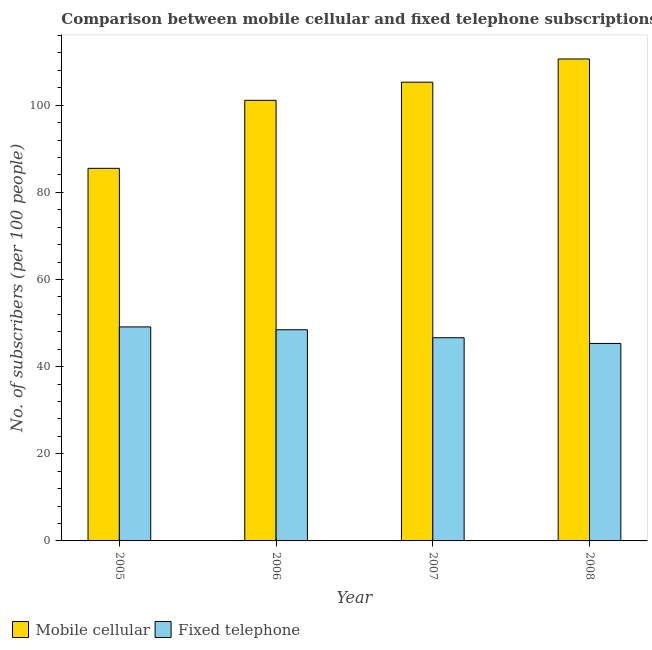How many different coloured bars are there?
Give a very brief answer. 2. Are the number of bars on each tick of the X-axis equal?
Offer a very short reply. Yes. How many bars are there on the 2nd tick from the left?
Your answer should be very brief. 2. What is the label of the 1st group of bars from the left?
Your answer should be very brief. 2005. In how many cases, is the number of bars for a given year not equal to the number of legend labels?
Make the answer very short. 0. What is the number of mobile cellular subscribers in 2007?
Provide a succinct answer. 105.28. Across all years, what is the maximum number of fixed telephone subscribers?
Provide a succinct answer. 49.11. Across all years, what is the minimum number of fixed telephone subscribers?
Provide a succinct answer. 45.32. In which year was the number of mobile cellular subscribers minimum?
Your answer should be very brief. 2005. What is the total number of fixed telephone subscribers in the graph?
Give a very brief answer. 189.53. What is the difference between the number of mobile cellular subscribers in 2006 and that in 2008?
Provide a succinct answer. -9.49. What is the difference between the number of mobile cellular subscribers in 2005 and the number of fixed telephone subscribers in 2006?
Give a very brief answer. -15.61. What is the average number of fixed telephone subscribers per year?
Your response must be concise. 47.38. In the year 2007, what is the difference between the number of fixed telephone subscribers and number of mobile cellular subscribers?
Your response must be concise. 0. What is the ratio of the number of mobile cellular subscribers in 2005 to that in 2008?
Provide a short and direct response. 0.77. Is the number of fixed telephone subscribers in 2005 less than that in 2006?
Offer a terse response. No. Is the difference between the number of mobile cellular subscribers in 2007 and 2008 greater than the difference between the number of fixed telephone subscribers in 2007 and 2008?
Give a very brief answer. No. What is the difference between the highest and the second highest number of fixed telephone subscribers?
Your answer should be very brief. 0.65. What is the difference between the highest and the lowest number of fixed telephone subscribers?
Offer a very short reply. 3.79. In how many years, is the number of mobile cellular subscribers greater than the average number of mobile cellular subscribers taken over all years?
Ensure brevity in your answer.  3. What does the 2nd bar from the left in 2005 represents?
Give a very brief answer. Fixed telephone. What does the 2nd bar from the right in 2008 represents?
Offer a terse response. Mobile cellular. How many bars are there?
Ensure brevity in your answer.  8. Are all the bars in the graph horizontal?
Offer a terse response. No. Does the graph contain any zero values?
Offer a very short reply. No. Where does the legend appear in the graph?
Ensure brevity in your answer.  Bottom left. What is the title of the graph?
Offer a terse response. Comparison between mobile cellular and fixed telephone subscriptions in Faeroe Islands. Does "Long-term debt" appear as one of the legend labels in the graph?
Keep it short and to the point. No. What is the label or title of the X-axis?
Keep it short and to the point. Year. What is the label or title of the Y-axis?
Give a very brief answer. No. of subscribers (per 100 people). What is the No. of subscribers (per 100 people) of Mobile cellular in 2005?
Your response must be concise. 85.51. What is the No. of subscribers (per 100 people) in Fixed telephone in 2005?
Offer a very short reply. 49.11. What is the No. of subscribers (per 100 people) of Mobile cellular in 2006?
Ensure brevity in your answer.  101.12. What is the No. of subscribers (per 100 people) of Fixed telephone in 2006?
Make the answer very short. 48.46. What is the No. of subscribers (per 100 people) of Mobile cellular in 2007?
Your answer should be compact. 105.28. What is the No. of subscribers (per 100 people) of Fixed telephone in 2007?
Offer a very short reply. 46.63. What is the No. of subscribers (per 100 people) in Mobile cellular in 2008?
Ensure brevity in your answer.  110.6. What is the No. of subscribers (per 100 people) in Fixed telephone in 2008?
Your response must be concise. 45.32. Across all years, what is the maximum No. of subscribers (per 100 people) of Mobile cellular?
Your response must be concise. 110.6. Across all years, what is the maximum No. of subscribers (per 100 people) of Fixed telephone?
Provide a succinct answer. 49.11. Across all years, what is the minimum No. of subscribers (per 100 people) of Mobile cellular?
Your response must be concise. 85.51. Across all years, what is the minimum No. of subscribers (per 100 people) of Fixed telephone?
Provide a short and direct response. 45.32. What is the total No. of subscribers (per 100 people) in Mobile cellular in the graph?
Provide a succinct answer. 402.5. What is the total No. of subscribers (per 100 people) in Fixed telephone in the graph?
Make the answer very short. 189.53. What is the difference between the No. of subscribers (per 100 people) of Mobile cellular in 2005 and that in 2006?
Your response must be concise. -15.61. What is the difference between the No. of subscribers (per 100 people) of Fixed telephone in 2005 and that in 2006?
Your answer should be very brief. 0.65. What is the difference between the No. of subscribers (per 100 people) of Mobile cellular in 2005 and that in 2007?
Give a very brief answer. -19.77. What is the difference between the No. of subscribers (per 100 people) of Fixed telephone in 2005 and that in 2007?
Ensure brevity in your answer.  2.48. What is the difference between the No. of subscribers (per 100 people) in Mobile cellular in 2005 and that in 2008?
Ensure brevity in your answer.  -25.1. What is the difference between the No. of subscribers (per 100 people) in Fixed telephone in 2005 and that in 2008?
Offer a terse response. 3.79. What is the difference between the No. of subscribers (per 100 people) in Mobile cellular in 2006 and that in 2007?
Provide a succinct answer. -4.16. What is the difference between the No. of subscribers (per 100 people) of Fixed telephone in 2006 and that in 2007?
Provide a short and direct response. 1.83. What is the difference between the No. of subscribers (per 100 people) in Mobile cellular in 2006 and that in 2008?
Give a very brief answer. -9.49. What is the difference between the No. of subscribers (per 100 people) of Fixed telephone in 2006 and that in 2008?
Ensure brevity in your answer.  3.14. What is the difference between the No. of subscribers (per 100 people) of Mobile cellular in 2007 and that in 2008?
Ensure brevity in your answer.  -5.33. What is the difference between the No. of subscribers (per 100 people) in Fixed telephone in 2007 and that in 2008?
Provide a short and direct response. 1.31. What is the difference between the No. of subscribers (per 100 people) in Mobile cellular in 2005 and the No. of subscribers (per 100 people) in Fixed telephone in 2006?
Your answer should be compact. 37.04. What is the difference between the No. of subscribers (per 100 people) in Mobile cellular in 2005 and the No. of subscribers (per 100 people) in Fixed telephone in 2007?
Make the answer very short. 38.87. What is the difference between the No. of subscribers (per 100 people) of Mobile cellular in 2005 and the No. of subscribers (per 100 people) of Fixed telephone in 2008?
Provide a short and direct response. 40.18. What is the difference between the No. of subscribers (per 100 people) in Mobile cellular in 2006 and the No. of subscribers (per 100 people) in Fixed telephone in 2007?
Give a very brief answer. 54.48. What is the difference between the No. of subscribers (per 100 people) of Mobile cellular in 2006 and the No. of subscribers (per 100 people) of Fixed telephone in 2008?
Your answer should be compact. 55.79. What is the difference between the No. of subscribers (per 100 people) in Mobile cellular in 2007 and the No. of subscribers (per 100 people) in Fixed telephone in 2008?
Give a very brief answer. 59.95. What is the average No. of subscribers (per 100 people) of Mobile cellular per year?
Ensure brevity in your answer.  100.63. What is the average No. of subscribers (per 100 people) in Fixed telephone per year?
Ensure brevity in your answer.  47.38. In the year 2005, what is the difference between the No. of subscribers (per 100 people) in Mobile cellular and No. of subscribers (per 100 people) in Fixed telephone?
Offer a terse response. 36.39. In the year 2006, what is the difference between the No. of subscribers (per 100 people) in Mobile cellular and No. of subscribers (per 100 people) in Fixed telephone?
Offer a very short reply. 52.65. In the year 2007, what is the difference between the No. of subscribers (per 100 people) of Mobile cellular and No. of subscribers (per 100 people) of Fixed telephone?
Your answer should be compact. 58.64. In the year 2008, what is the difference between the No. of subscribers (per 100 people) in Mobile cellular and No. of subscribers (per 100 people) in Fixed telephone?
Make the answer very short. 65.28. What is the ratio of the No. of subscribers (per 100 people) of Mobile cellular in 2005 to that in 2006?
Provide a short and direct response. 0.85. What is the ratio of the No. of subscribers (per 100 people) in Fixed telephone in 2005 to that in 2006?
Offer a terse response. 1.01. What is the ratio of the No. of subscribers (per 100 people) of Mobile cellular in 2005 to that in 2007?
Your response must be concise. 0.81. What is the ratio of the No. of subscribers (per 100 people) in Fixed telephone in 2005 to that in 2007?
Your response must be concise. 1.05. What is the ratio of the No. of subscribers (per 100 people) in Mobile cellular in 2005 to that in 2008?
Make the answer very short. 0.77. What is the ratio of the No. of subscribers (per 100 people) of Fixed telephone in 2005 to that in 2008?
Ensure brevity in your answer.  1.08. What is the ratio of the No. of subscribers (per 100 people) of Mobile cellular in 2006 to that in 2007?
Offer a very short reply. 0.96. What is the ratio of the No. of subscribers (per 100 people) in Fixed telephone in 2006 to that in 2007?
Provide a succinct answer. 1.04. What is the ratio of the No. of subscribers (per 100 people) in Mobile cellular in 2006 to that in 2008?
Offer a very short reply. 0.91. What is the ratio of the No. of subscribers (per 100 people) of Fixed telephone in 2006 to that in 2008?
Your response must be concise. 1.07. What is the ratio of the No. of subscribers (per 100 people) of Mobile cellular in 2007 to that in 2008?
Ensure brevity in your answer.  0.95. What is the ratio of the No. of subscribers (per 100 people) in Fixed telephone in 2007 to that in 2008?
Provide a succinct answer. 1.03. What is the difference between the highest and the second highest No. of subscribers (per 100 people) in Mobile cellular?
Offer a terse response. 5.33. What is the difference between the highest and the second highest No. of subscribers (per 100 people) in Fixed telephone?
Keep it short and to the point. 0.65. What is the difference between the highest and the lowest No. of subscribers (per 100 people) of Mobile cellular?
Make the answer very short. 25.1. What is the difference between the highest and the lowest No. of subscribers (per 100 people) of Fixed telephone?
Make the answer very short. 3.79. 